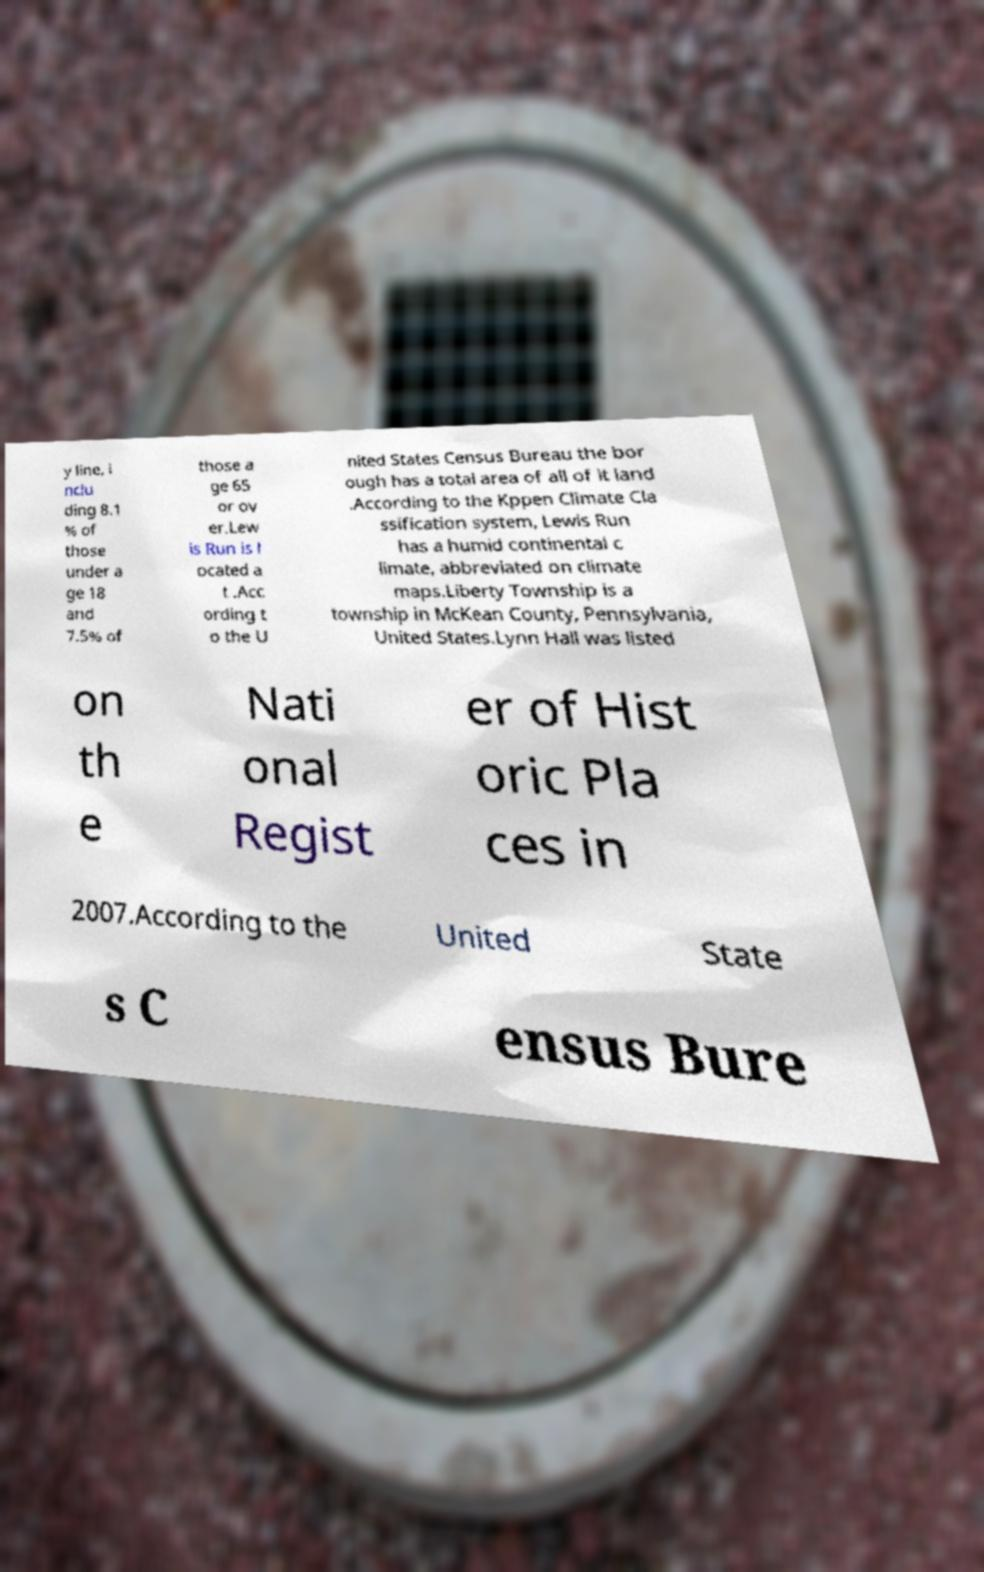For documentation purposes, I need the text within this image transcribed. Could you provide that? y line, i nclu ding 8.1 % of those under a ge 18 and 7.5% of those a ge 65 or ov er.Lew is Run is l ocated a t .Acc ording t o the U nited States Census Bureau the bor ough has a total area of all of it land .According to the Kppen Climate Cla ssification system, Lewis Run has a humid continental c limate, abbreviated on climate maps.Liberty Township is a township in McKean County, Pennsylvania, United States.Lynn Hall was listed on th e Nati onal Regist er of Hist oric Pla ces in 2007.According to the United State s C ensus Bure 